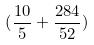<formula> <loc_0><loc_0><loc_500><loc_500>( \frac { 1 0 } { 5 } + \frac { 2 8 4 } { 5 2 } )</formula> 